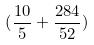<formula> <loc_0><loc_0><loc_500><loc_500>( \frac { 1 0 } { 5 } + \frac { 2 8 4 } { 5 2 } )</formula> 